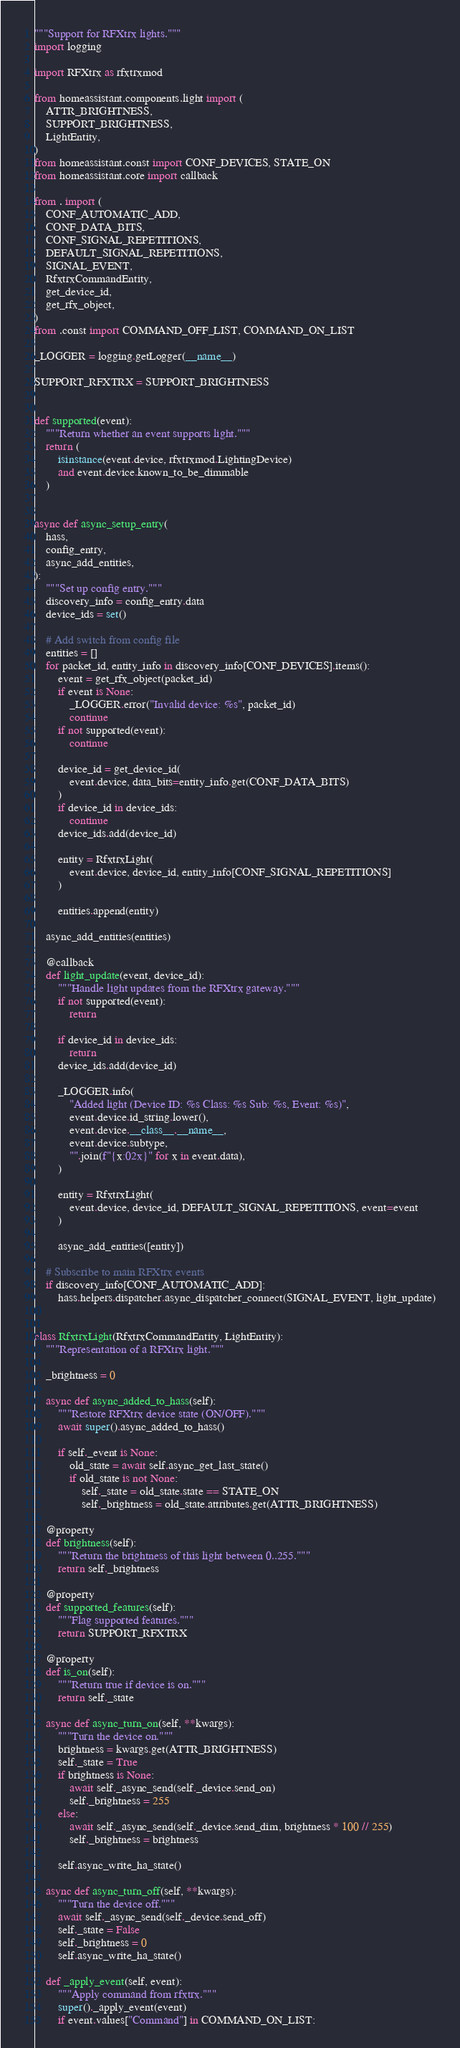<code> <loc_0><loc_0><loc_500><loc_500><_Python_>"""Support for RFXtrx lights."""
import logging

import RFXtrx as rfxtrxmod

from homeassistant.components.light import (
    ATTR_BRIGHTNESS,
    SUPPORT_BRIGHTNESS,
    LightEntity,
)
from homeassistant.const import CONF_DEVICES, STATE_ON
from homeassistant.core import callback

from . import (
    CONF_AUTOMATIC_ADD,
    CONF_DATA_BITS,
    CONF_SIGNAL_REPETITIONS,
    DEFAULT_SIGNAL_REPETITIONS,
    SIGNAL_EVENT,
    RfxtrxCommandEntity,
    get_device_id,
    get_rfx_object,
)
from .const import COMMAND_OFF_LIST, COMMAND_ON_LIST

_LOGGER = logging.getLogger(__name__)

SUPPORT_RFXTRX = SUPPORT_BRIGHTNESS


def supported(event):
    """Return whether an event supports light."""
    return (
        isinstance(event.device, rfxtrxmod.LightingDevice)
        and event.device.known_to_be_dimmable
    )


async def async_setup_entry(
    hass,
    config_entry,
    async_add_entities,
):
    """Set up config entry."""
    discovery_info = config_entry.data
    device_ids = set()

    # Add switch from config file
    entities = []
    for packet_id, entity_info in discovery_info[CONF_DEVICES].items():
        event = get_rfx_object(packet_id)
        if event is None:
            _LOGGER.error("Invalid device: %s", packet_id)
            continue
        if not supported(event):
            continue

        device_id = get_device_id(
            event.device, data_bits=entity_info.get(CONF_DATA_BITS)
        )
        if device_id in device_ids:
            continue
        device_ids.add(device_id)

        entity = RfxtrxLight(
            event.device, device_id, entity_info[CONF_SIGNAL_REPETITIONS]
        )

        entities.append(entity)

    async_add_entities(entities)

    @callback
    def light_update(event, device_id):
        """Handle light updates from the RFXtrx gateway."""
        if not supported(event):
            return

        if device_id in device_ids:
            return
        device_ids.add(device_id)

        _LOGGER.info(
            "Added light (Device ID: %s Class: %s Sub: %s, Event: %s)",
            event.device.id_string.lower(),
            event.device.__class__.__name__,
            event.device.subtype,
            "".join(f"{x:02x}" for x in event.data),
        )

        entity = RfxtrxLight(
            event.device, device_id, DEFAULT_SIGNAL_REPETITIONS, event=event
        )

        async_add_entities([entity])

    # Subscribe to main RFXtrx events
    if discovery_info[CONF_AUTOMATIC_ADD]:
        hass.helpers.dispatcher.async_dispatcher_connect(SIGNAL_EVENT, light_update)


class RfxtrxLight(RfxtrxCommandEntity, LightEntity):
    """Representation of a RFXtrx light."""

    _brightness = 0

    async def async_added_to_hass(self):
        """Restore RFXtrx device state (ON/OFF)."""
        await super().async_added_to_hass()

        if self._event is None:
            old_state = await self.async_get_last_state()
            if old_state is not None:
                self._state = old_state.state == STATE_ON
                self._brightness = old_state.attributes.get(ATTR_BRIGHTNESS)

    @property
    def brightness(self):
        """Return the brightness of this light between 0..255."""
        return self._brightness

    @property
    def supported_features(self):
        """Flag supported features."""
        return SUPPORT_RFXTRX

    @property
    def is_on(self):
        """Return true if device is on."""
        return self._state

    async def async_turn_on(self, **kwargs):
        """Turn the device on."""
        brightness = kwargs.get(ATTR_BRIGHTNESS)
        self._state = True
        if brightness is None:
            await self._async_send(self._device.send_on)
            self._brightness = 255
        else:
            await self._async_send(self._device.send_dim, brightness * 100 // 255)
            self._brightness = brightness

        self.async_write_ha_state()

    async def async_turn_off(self, **kwargs):
        """Turn the device off."""
        await self._async_send(self._device.send_off)
        self._state = False
        self._brightness = 0
        self.async_write_ha_state()

    def _apply_event(self, event):
        """Apply command from rfxtrx."""
        super()._apply_event(event)
        if event.values["Command"] in COMMAND_ON_LIST:</code> 